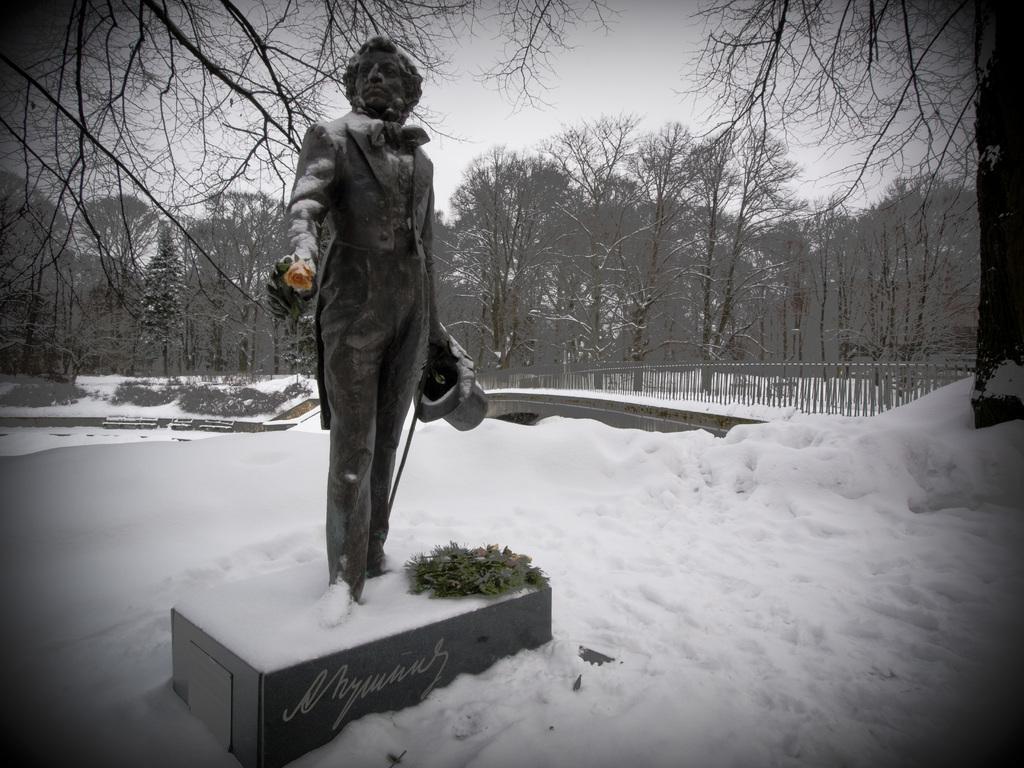Please provide a concise description of this image. In this picture there is a statue of a person in the foreground and there is a plant and there is a text on the wall. At the back there is a bridge and there are trees. At the bottom there is snow. 